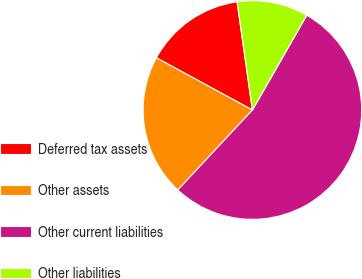<chart> <loc_0><loc_0><loc_500><loc_500><pie_chart><fcel>Deferred tax assets<fcel>Other assets<fcel>Other current liabilities<fcel>Other liabilities<nl><fcel>14.83%<fcel>20.98%<fcel>53.66%<fcel>10.52%<nl></chart> 